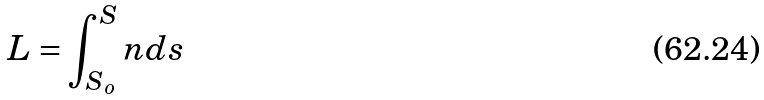<formula> <loc_0><loc_0><loc_500><loc_500>L = \int _ { S _ { o } } ^ { S } n d s</formula> 